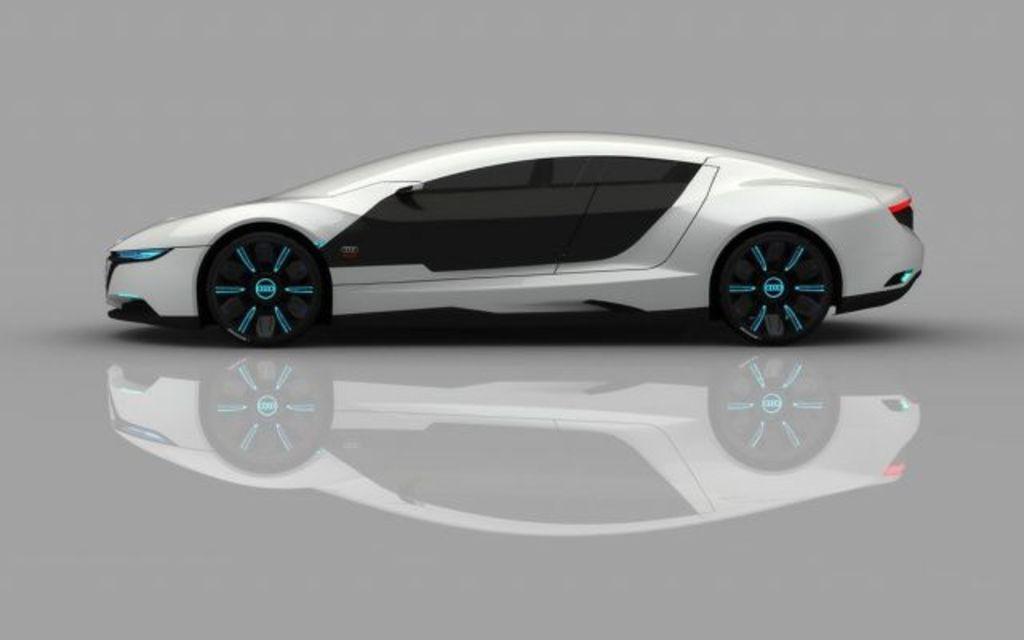Can you describe this image briefly? In the center of the image, we can see a car and at the bottom, there is floor. 